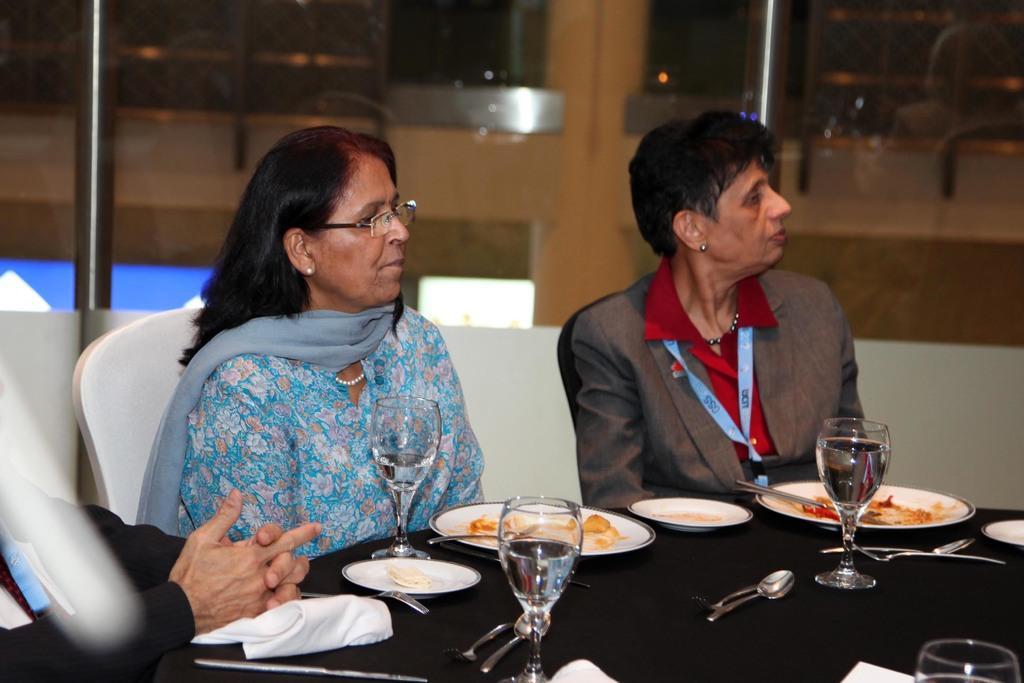Please provide a concise description of this image. In this image, we can see people sitting and wearing id cards and one of them is wearing glasses. At the bottom, we can see plates with food and there are spoons, forks, tissues and there are glasses containing liquid. In the background, there are rods and glass doors and there is a wall. 